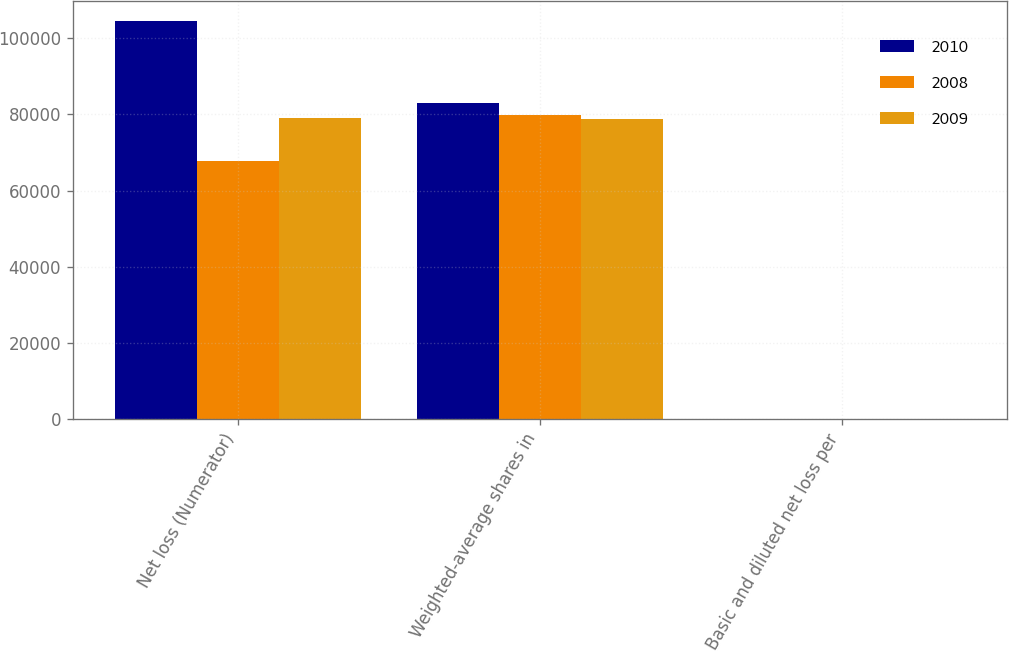<chart> <loc_0><loc_0><loc_500><loc_500><stacked_bar_chart><ecel><fcel>Net loss (Numerator)<fcel>Weighted-average shares in<fcel>Basic and diluted net loss per<nl><fcel>2010<fcel>104468<fcel>82926<fcel>1.26<nl><fcel>2008<fcel>67830<fcel>79782<fcel>0.85<nl><fcel>2009<fcel>79129<fcel>78827<fcel>1<nl></chart> 